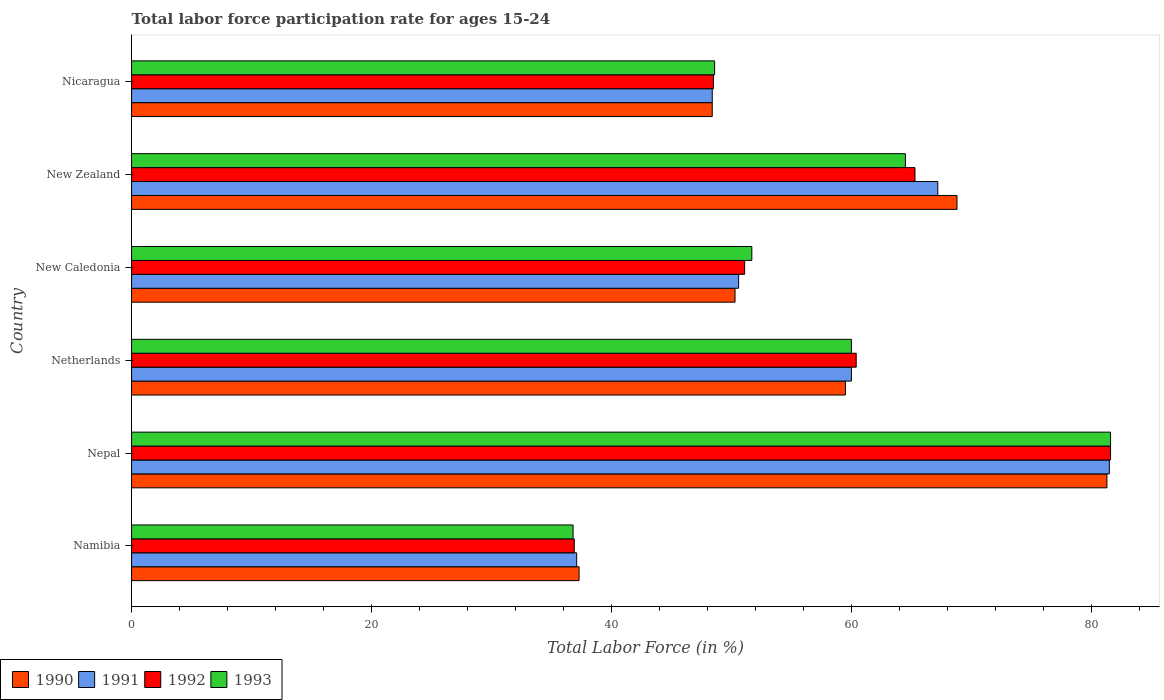How many different coloured bars are there?
Provide a short and direct response. 4. Are the number of bars on each tick of the Y-axis equal?
Ensure brevity in your answer.  Yes. How many bars are there on the 5th tick from the top?
Give a very brief answer. 4. What is the label of the 2nd group of bars from the top?
Make the answer very short. New Zealand. What is the labor force participation rate in 1992 in Namibia?
Keep it short and to the point. 36.9. Across all countries, what is the maximum labor force participation rate in 1993?
Your answer should be very brief. 81.6. Across all countries, what is the minimum labor force participation rate in 1993?
Your answer should be compact. 36.8. In which country was the labor force participation rate in 1990 maximum?
Provide a succinct answer. Nepal. In which country was the labor force participation rate in 1993 minimum?
Your answer should be very brief. Namibia. What is the total labor force participation rate in 1990 in the graph?
Provide a short and direct response. 345.6. What is the difference between the labor force participation rate in 1993 in Namibia and that in Netherlands?
Provide a short and direct response. -23.2. What is the difference between the labor force participation rate in 1992 in Namibia and the labor force participation rate in 1991 in New Zealand?
Provide a short and direct response. -30.3. What is the average labor force participation rate in 1993 per country?
Your answer should be very brief. 57.2. What is the difference between the labor force participation rate in 1990 and labor force participation rate in 1993 in Nicaragua?
Make the answer very short. -0.2. What is the ratio of the labor force participation rate in 1991 in Nepal to that in New Caledonia?
Your response must be concise. 1.61. Is the labor force participation rate in 1990 in Namibia less than that in Nepal?
Make the answer very short. Yes. Is the difference between the labor force participation rate in 1990 in New Caledonia and Nicaragua greater than the difference between the labor force participation rate in 1993 in New Caledonia and Nicaragua?
Ensure brevity in your answer.  No. What is the difference between the highest and the second highest labor force participation rate in 1991?
Your answer should be very brief. 14.3. What is the difference between the highest and the lowest labor force participation rate in 1992?
Your answer should be very brief. 44.7. In how many countries, is the labor force participation rate in 1992 greater than the average labor force participation rate in 1992 taken over all countries?
Offer a terse response. 3. Is the sum of the labor force participation rate in 1993 in Nepal and Netherlands greater than the maximum labor force participation rate in 1992 across all countries?
Give a very brief answer. Yes. Is it the case that in every country, the sum of the labor force participation rate in 1991 and labor force participation rate in 1992 is greater than the sum of labor force participation rate in 1990 and labor force participation rate in 1993?
Provide a short and direct response. No. What does the 1st bar from the top in Namibia represents?
Offer a terse response. 1993. What does the 1st bar from the bottom in Nepal represents?
Provide a short and direct response. 1990. Is it the case that in every country, the sum of the labor force participation rate in 1992 and labor force participation rate in 1991 is greater than the labor force participation rate in 1990?
Ensure brevity in your answer.  Yes. Are all the bars in the graph horizontal?
Your answer should be compact. Yes. Are the values on the major ticks of X-axis written in scientific E-notation?
Keep it short and to the point. No. Where does the legend appear in the graph?
Provide a short and direct response. Bottom left. What is the title of the graph?
Your answer should be very brief. Total labor force participation rate for ages 15-24. What is the Total Labor Force (in %) of 1990 in Namibia?
Provide a succinct answer. 37.3. What is the Total Labor Force (in %) in 1991 in Namibia?
Provide a short and direct response. 37.1. What is the Total Labor Force (in %) of 1992 in Namibia?
Your response must be concise. 36.9. What is the Total Labor Force (in %) of 1993 in Namibia?
Provide a succinct answer. 36.8. What is the Total Labor Force (in %) in 1990 in Nepal?
Your response must be concise. 81.3. What is the Total Labor Force (in %) of 1991 in Nepal?
Make the answer very short. 81.5. What is the Total Labor Force (in %) of 1992 in Nepal?
Provide a short and direct response. 81.6. What is the Total Labor Force (in %) of 1993 in Nepal?
Keep it short and to the point. 81.6. What is the Total Labor Force (in %) of 1990 in Netherlands?
Your answer should be compact. 59.5. What is the Total Labor Force (in %) of 1992 in Netherlands?
Give a very brief answer. 60.4. What is the Total Labor Force (in %) of 1990 in New Caledonia?
Your answer should be very brief. 50.3. What is the Total Labor Force (in %) in 1991 in New Caledonia?
Offer a terse response. 50.6. What is the Total Labor Force (in %) in 1992 in New Caledonia?
Give a very brief answer. 51.1. What is the Total Labor Force (in %) of 1993 in New Caledonia?
Keep it short and to the point. 51.7. What is the Total Labor Force (in %) in 1990 in New Zealand?
Give a very brief answer. 68.8. What is the Total Labor Force (in %) in 1991 in New Zealand?
Offer a terse response. 67.2. What is the Total Labor Force (in %) in 1992 in New Zealand?
Make the answer very short. 65.3. What is the Total Labor Force (in %) in 1993 in New Zealand?
Keep it short and to the point. 64.5. What is the Total Labor Force (in %) in 1990 in Nicaragua?
Your response must be concise. 48.4. What is the Total Labor Force (in %) of 1991 in Nicaragua?
Provide a short and direct response. 48.4. What is the Total Labor Force (in %) of 1992 in Nicaragua?
Give a very brief answer. 48.5. What is the Total Labor Force (in %) of 1993 in Nicaragua?
Give a very brief answer. 48.6. Across all countries, what is the maximum Total Labor Force (in %) in 1990?
Your answer should be very brief. 81.3. Across all countries, what is the maximum Total Labor Force (in %) of 1991?
Ensure brevity in your answer.  81.5. Across all countries, what is the maximum Total Labor Force (in %) of 1992?
Your response must be concise. 81.6. Across all countries, what is the maximum Total Labor Force (in %) of 1993?
Make the answer very short. 81.6. Across all countries, what is the minimum Total Labor Force (in %) of 1990?
Give a very brief answer. 37.3. Across all countries, what is the minimum Total Labor Force (in %) of 1991?
Offer a terse response. 37.1. Across all countries, what is the minimum Total Labor Force (in %) in 1992?
Ensure brevity in your answer.  36.9. Across all countries, what is the minimum Total Labor Force (in %) in 1993?
Give a very brief answer. 36.8. What is the total Total Labor Force (in %) of 1990 in the graph?
Keep it short and to the point. 345.6. What is the total Total Labor Force (in %) of 1991 in the graph?
Your response must be concise. 344.8. What is the total Total Labor Force (in %) in 1992 in the graph?
Provide a succinct answer. 343.8. What is the total Total Labor Force (in %) in 1993 in the graph?
Keep it short and to the point. 343.2. What is the difference between the Total Labor Force (in %) in 1990 in Namibia and that in Nepal?
Your answer should be compact. -44. What is the difference between the Total Labor Force (in %) of 1991 in Namibia and that in Nepal?
Your answer should be compact. -44.4. What is the difference between the Total Labor Force (in %) in 1992 in Namibia and that in Nepal?
Provide a succinct answer. -44.7. What is the difference between the Total Labor Force (in %) of 1993 in Namibia and that in Nepal?
Your response must be concise. -44.8. What is the difference between the Total Labor Force (in %) of 1990 in Namibia and that in Netherlands?
Make the answer very short. -22.2. What is the difference between the Total Labor Force (in %) of 1991 in Namibia and that in Netherlands?
Your answer should be compact. -22.9. What is the difference between the Total Labor Force (in %) in 1992 in Namibia and that in Netherlands?
Offer a very short reply. -23.5. What is the difference between the Total Labor Force (in %) of 1993 in Namibia and that in Netherlands?
Provide a succinct answer. -23.2. What is the difference between the Total Labor Force (in %) of 1990 in Namibia and that in New Caledonia?
Offer a terse response. -13. What is the difference between the Total Labor Force (in %) of 1991 in Namibia and that in New Caledonia?
Your answer should be very brief. -13.5. What is the difference between the Total Labor Force (in %) in 1992 in Namibia and that in New Caledonia?
Your response must be concise. -14.2. What is the difference between the Total Labor Force (in %) in 1993 in Namibia and that in New Caledonia?
Offer a terse response. -14.9. What is the difference between the Total Labor Force (in %) of 1990 in Namibia and that in New Zealand?
Provide a succinct answer. -31.5. What is the difference between the Total Labor Force (in %) of 1991 in Namibia and that in New Zealand?
Make the answer very short. -30.1. What is the difference between the Total Labor Force (in %) of 1992 in Namibia and that in New Zealand?
Provide a succinct answer. -28.4. What is the difference between the Total Labor Force (in %) in 1993 in Namibia and that in New Zealand?
Your response must be concise. -27.7. What is the difference between the Total Labor Force (in %) in 1990 in Namibia and that in Nicaragua?
Make the answer very short. -11.1. What is the difference between the Total Labor Force (in %) of 1992 in Namibia and that in Nicaragua?
Ensure brevity in your answer.  -11.6. What is the difference between the Total Labor Force (in %) of 1990 in Nepal and that in Netherlands?
Give a very brief answer. 21.8. What is the difference between the Total Labor Force (in %) in 1991 in Nepal and that in Netherlands?
Ensure brevity in your answer.  21.5. What is the difference between the Total Labor Force (in %) in 1992 in Nepal and that in Netherlands?
Offer a terse response. 21.2. What is the difference between the Total Labor Force (in %) of 1993 in Nepal and that in Netherlands?
Ensure brevity in your answer.  21.6. What is the difference between the Total Labor Force (in %) in 1991 in Nepal and that in New Caledonia?
Offer a terse response. 30.9. What is the difference between the Total Labor Force (in %) of 1992 in Nepal and that in New Caledonia?
Make the answer very short. 30.5. What is the difference between the Total Labor Force (in %) of 1993 in Nepal and that in New Caledonia?
Provide a short and direct response. 29.9. What is the difference between the Total Labor Force (in %) in 1992 in Nepal and that in New Zealand?
Offer a terse response. 16.3. What is the difference between the Total Labor Force (in %) in 1990 in Nepal and that in Nicaragua?
Keep it short and to the point. 32.9. What is the difference between the Total Labor Force (in %) of 1991 in Nepal and that in Nicaragua?
Ensure brevity in your answer.  33.1. What is the difference between the Total Labor Force (in %) of 1992 in Nepal and that in Nicaragua?
Your response must be concise. 33.1. What is the difference between the Total Labor Force (in %) of 1993 in Nepal and that in Nicaragua?
Keep it short and to the point. 33. What is the difference between the Total Labor Force (in %) in 1991 in Netherlands and that in New Caledonia?
Give a very brief answer. 9.4. What is the difference between the Total Labor Force (in %) in 1993 in Netherlands and that in New Caledonia?
Ensure brevity in your answer.  8.3. What is the difference between the Total Labor Force (in %) in 1991 in Netherlands and that in New Zealand?
Your answer should be very brief. -7.2. What is the difference between the Total Labor Force (in %) of 1993 in Netherlands and that in New Zealand?
Your response must be concise. -4.5. What is the difference between the Total Labor Force (in %) of 1990 in Netherlands and that in Nicaragua?
Your answer should be compact. 11.1. What is the difference between the Total Labor Force (in %) in 1991 in Netherlands and that in Nicaragua?
Your answer should be very brief. 11.6. What is the difference between the Total Labor Force (in %) in 1990 in New Caledonia and that in New Zealand?
Your answer should be compact. -18.5. What is the difference between the Total Labor Force (in %) in 1991 in New Caledonia and that in New Zealand?
Ensure brevity in your answer.  -16.6. What is the difference between the Total Labor Force (in %) in 1992 in New Caledonia and that in Nicaragua?
Your response must be concise. 2.6. What is the difference between the Total Labor Force (in %) of 1990 in New Zealand and that in Nicaragua?
Provide a succinct answer. 20.4. What is the difference between the Total Labor Force (in %) of 1991 in New Zealand and that in Nicaragua?
Ensure brevity in your answer.  18.8. What is the difference between the Total Labor Force (in %) in 1993 in New Zealand and that in Nicaragua?
Your answer should be compact. 15.9. What is the difference between the Total Labor Force (in %) of 1990 in Namibia and the Total Labor Force (in %) of 1991 in Nepal?
Offer a terse response. -44.2. What is the difference between the Total Labor Force (in %) of 1990 in Namibia and the Total Labor Force (in %) of 1992 in Nepal?
Give a very brief answer. -44.3. What is the difference between the Total Labor Force (in %) in 1990 in Namibia and the Total Labor Force (in %) in 1993 in Nepal?
Offer a very short reply. -44.3. What is the difference between the Total Labor Force (in %) in 1991 in Namibia and the Total Labor Force (in %) in 1992 in Nepal?
Your answer should be compact. -44.5. What is the difference between the Total Labor Force (in %) in 1991 in Namibia and the Total Labor Force (in %) in 1993 in Nepal?
Keep it short and to the point. -44.5. What is the difference between the Total Labor Force (in %) of 1992 in Namibia and the Total Labor Force (in %) of 1993 in Nepal?
Your answer should be compact. -44.7. What is the difference between the Total Labor Force (in %) of 1990 in Namibia and the Total Labor Force (in %) of 1991 in Netherlands?
Offer a very short reply. -22.7. What is the difference between the Total Labor Force (in %) of 1990 in Namibia and the Total Labor Force (in %) of 1992 in Netherlands?
Your response must be concise. -23.1. What is the difference between the Total Labor Force (in %) of 1990 in Namibia and the Total Labor Force (in %) of 1993 in Netherlands?
Your answer should be very brief. -22.7. What is the difference between the Total Labor Force (in %) in 1991 in Namibia and the Total Labor Force (in %) in 1992 in Netherlands?
Provide a succinct answer. -23.3. What is the difference between the Total Labor Force (in %) in 1991 in Namibia and the Total Labor Force (in %) in 1993 in Netherlands?
Make the answer very short. -22.9. What is the difference between the Total Labor Force (in %) of 1992 in Namibia and the Total Labor Force (in %) of 1993 in Netherlands?
Make the answer very short. -23.1. What is the difference between the Total Labor Force (in %) of 1990 in Namibia and the Total Labor Force (in %) of 1991 in New Caledonia?
Give a very brief answer. -13.3. What is the difference between the Total Labor Force (in %) of 1990 in Namibia and the Total Labor Force (in %) of 1993 in New Caledonia?
Keep it short and to the point. -14.4. What is the difference between the Total Labor Force (in %) in 1991 in Namibia and the Total Labor Force (in %) in 1992 in New Caledonia?
Ensure brevity in your answer.  -14. What is the difference between the Total Labor Force (in %) in 1991 in Namibia and the Total Labor Force (in %) in 1993 in New Caledonia?
Your response must be concise. -14.6. What is the difference between the Total Labor Force (in %) of 1992 in Namibia and the Total Labor Force (in %) of 1993 in New Caledonia?
Provide a short and direct response. -14.8. What is the difference between the Total Labor Force (in %) in 1990 in Namibia and the Total Labor Force (in %) in 1991 in New Zealand?
Give a very brief answer. -29.9. What is the difference between the Total Labor Force (in %) of 1990 in Namibia and the Total Labor Force (in %) of 1993 in New Zealand?
Ensure brevity in your answer.  -27.2. What is the difference between the Total Labor Force (in %) of 1991 in Namibia and the Total Labor Force (in %) of 1992 in New Zealand?
Provide a short and direct response. -28.2. What is the difference between the Total Labor Force (in %) of 1991 in Namibia and the Total Labor Force (in %) of 1993 in New Zealand?
Offer a very short reply. -27.4. What is the difference between the Total Labor Force (in %) in 1992 in Namibia and the Total Labor Force (in %) in 1993 in New Zealand?
Offer a very short reply. -27.6. What is the difference between the Total Labor Force (in %) of 1990 in Namibia and the Total Labor Force (in %) of 1993 in Nicaragua?
Provide a short and direct response. -11.3. What is the difference between the Total Labor Force (in %) in 1991 in Namibia and the Total Labor Force (in %) in 1992 in Nicaragua?
Offer a very short reply. -11.4. What is the difference between the Total Labor Force (in %) of 1991 in Namibia and the Total Labor Force (in %) of 1993 in Nicaragua?
Give a very brief answer. -11.5. What is the difference between the Total Labor Force (in %) of 1992 in Namibia and the Total Labor Force (in %) of 1993 in Nicaragua?
Provide a short and direct response. -11.7. What is the difference between the Total Labor Force (in %) of 1990 in Nepal and the Total Labor Force (in %) of 1991 in Netherlands?
Your response must be concise. 21.3. What is the difference between the Total Labor Force (in %) of 1990 in Nepal and the Total Labor Force (in %) of 1992 in Netherlands?
Offer a terse response. 20.9. What is the difference between the Total Labor Force (in %) in 1990 in Nepal and the Total Labor Force (in %) in 1993 in Netherlands?
Your response must be concise. 21.3. What is the difference between the Total Labor Force (in %) in 1991 in Nepal and the Total Labor Force (in %) in 1992 in Netherlands?
Provide a succinct answer. 21.1. What is the difference between the Total Labor Force (in %) of 1992 in Nepal and the Total Labor Force (in %) of 1993 in Netherlands?
Your answer should be compact. 21.6. What is the difference between the Total Labor Force (in %) in 1990 in Nepal and the Total Labor Force (in %) in 1991 in New Caledonia?
Keep it short and to the point. 30.7. What is the difference between the Total Labor Force (in %) in 1990 in Nepal and the Total Labor Force (in %) in 1992 in New Caledonia?
Ensure brevity in your answer.  30.2. What is the difference between the Total Labor Force (in %) of 1990 in Nepal and the Total Labor Force (in %) of 1993 in New Caledonia?
Your answer should be compact. 29.6. What is the difference between the Total Labor Force (in %) of 1991 in Nepal and the Total Labor Force (in %) of 1992 in New Caledonia?
Offer a terse response. 30.4. What is the difference between the Total Labor Force (in %) in 1991 in Nepal and the Total Labor Force (in %) in 1993 in New Caledonia?
Provide a succinct answer. 29.8. What is the difference between the Total Labor Force (in %) of 1992 in Nepal and the Total Labor Force (in %) of 1993 in New Caledonia?
Ensure brevity in your answer.  29.9. What is the difference between the Total Labor Force (in %) in 1990 in Nepal and the Total Labor Force (in %) in 1991 in New Zealand?
Ensure brevity in your answer.  14.1. What is the difference between the Total Labor Force (in %) in 1990 in Nepal and the Total Labor Force (in %) in 1992 in New Zealand?
Your answer should be very brief. 16. What is the difference between the Total Labor Force (in %) of 1990 in Nepal and the Total Labor Force (in %) of 1993 in New Zealand?
Keep it short and to the point. 16.8. What is the difference between the Total Labor Force (in %) in 1992 in Nepal and the Total Labor Force (in %) in 1993 in New Zealand?
Keep it short and to the point. 17.1. What is the difference between the Total Labor Force (in %) of 1990 in Nepal and the Total Labor Force (in %) of 1991 in Nicaragua?
Your answer should be very brief. 32.9. What is the difference between the Total Labor Force (in %) in 1990 in Nepal and the Total Labor Force (in %) in 1992 in Nicaragua?
Offer a very short reply. 32.8. What is the difference between the Total Labor Force (in %) in 1990 in Nepal and the Total Labor Force (in %) in 1993 in Nicaragua?
Provide a succinct answer. 32.7. What is the difference between the Total Labor Force (in %) of 1991 in Nepal and the Total Labor Force (in %) of 1993 in Nicaragua?
Your answer should be very brief. 32.9. What is the difference between the Total Labor Force (in %) in 1992 in Nepal and the Total Labor Force (in %) in 1993 in Nicaragua?
Offer a terse response. 33. What is the difference between the Total Labor Force (in %) of 1990 in Netherlands and the Total Labor Force (in %) of 1992 in New Caledonia?
Offer a very short reply. 8.4. What is the difference between the Total Labor Force (in %) of 1992 in Netherlands and the Total Labor Force (in %) of 1993 in New Caledonia?
Give a very brief answer. 8.7. What is the difference between the Total Labor Force (in %) in 1991 in Netherlands and the Total Labor Force (in %) in 1992 in New Zealand?
Give a very brief answer. -5.3. What is the difference between the Total Labor Force (in %) of 1992 in Netherlands and the Total Labor Force (in %) of 1993 in Nicaragua?
Give a very brief answer. 11.8. What is the difference between the Total Labor Force (in %) of 1990 in New Caledonia and the Total Labor Force (in %) of 1991 in New Zealand?
Provide a succinct answer. -16.9. What is the difference between the Total Labor Force (in %) in 1990 in New Caledonia and the Total Labor Force (in %) in 1992 in New Zealand?
Make the answer very short. -15. What is the difference between the Total Labor Force (in %) of 1990 in New Caledonia and the Total Labor Force (in %) of 1993 in New Zealand?
Ensure brevity in your answer.  -14.2. What is the difference between the Total Labor Force (in %) in 1991 in New Caledonia and the Total Labor Force (in %) in 1992 in New Zealand?
Your answer should be compact. -14.7. What is the difference between the Total Labor Force (in %) of 1991 in New Caledonia and the Total Labor Force (in %) of 1993 in New Zealand?
Provide a short and direct response. -13.9. What is the difference between the Total Labor Force (in %) in 1992 in New Caledonia and the Total Labor Force (in %) in 1993 in New Zealand?
Provide a short and direct response. -13.4. What is the difference between the Total Labor Force (in %) in 1990 in New Caledonia and the Total Labor Force (in %) in 1991 in Nicaragua?
Your answer should be compact. 1.9. What is the difference between the Total Labor Force (in %) of 1990 in New Caledonia and the Total Labor Force (in %) of 1992 in Nicaragua?
Your response must be concise. 1.8. What is the difference between the Total Labor Force (in %) in 1991 in New Caledonia and the Total Labor Force (in %) in 1992 in Nicaragua?
Provide a short and direct response. 2.1. What is the difference between the Total Labor Force (in %) of 1991 in New Caledonia and the Total Labor Force (in %) of 1993 in Nicaragua?
Ensure brevity in your answer.  2. What is the difference between the Total Labor Force (in %) in 1992 in New Caledonia and the Total Labor Force (in %) in 1993 in Nicaragua?
Keep it short and to the point. 2.5. What is the difference between the Total Labor Force (in %) in 1990 in New Zealand and the Total Labor Force (in %) in 1991 in Nicaragua?
Make the answer very short. 20.4. What is the difference between the Total Labor Force (in %) of 1990 in New Zealand and the Total Labor Force (in %) of 1992 in Nicaragua?
Ensure brevity in your answer.  20.3. What is the difference between the Total Labor Force (in %) in 1990 in New Zealand and the Total Labor Force (in %) in 1993 in Nicaragua?
Your response must be concise. 20.2. What is the difference between the Total Labor Force (in %) of 1991 in New Zealand and the Total Labor Force (in %) of 1992 in Nicaragua?
Your answer should be very brief. 18.7. What is the difference between the Total Labor Force (in %) of 1992 in New Zealand and the Total Labor Force (in %) of 1993 in Nicaragua?
Your response must be concise. 16.7. What is the average Total Labor Force (in %) in 1990 per country?
Keep it short and to the point. 57.6. What is the average Total Labor Force (in %) in 1991 per country?
Provide a succinct answer. 57.47. What is the average Total Labor Force (in %) of 1992 per country?
Your response must be concise. 57.3. What is the average Total Labor Force (in %) of 1993 per country?
Your answer should be compact. 57.2. What is the difference between the Total Labor Force (in %) of 1990 and Total Labor Force (in %) of 1992 in Namibia?
Keep it short and to the point. 0.4. What is the difference between the Total Labor Force (in %) of 1991 and Total Labor Force (in %) of 1992 in Namibia?
Your answer should be very brief. 0.2. What is the difference between the Total Labor Force (in %) of 1990 and Total Labor Force (in %) of 1992 in Nepal?
Your answer should be compact. -0.3. What is the difference between the Total Labor Force (in %) in 1990 and Total Labor Force (in %) in 1993 in Nepal?
Keep it short and to the point. -0.3. What is the difference between the Total Labor Force (in %) of 1991 and Total Labor Force (in %) of 1992 in Nepal?
Offer a terse response. -0.1. What is the difference between the Total Labor Force (in %) of 1992 and Total Labor Force (in %) of 1993 in Nepal?
Ensure brevity in your answer.  0. What is the difference between the Total Labor Force (in %) of 1990 and Total Labor Force (in %) of 1992 in Netherlands?
Ensure brevity in your answer.  -0.9. What is the difference between the Total Labor Force (in %) of 1991 and Total Labor Force (in %) of 1993 in Netherlands?
Give a very brief answer. 0. What is the difference between the Total Labor Force (in %) of 1992 and Total Labor Force (in %) of 1993 in Netherlands?
Provide a short and direct response. 0.4. What is the difference between the Total Labor Force (in %) in 1990 and Total Labor Force (in %) in 1991 in New Zealand?
Offer a terse response. 1.6. What is the difference between the Total Labor Force (in %) in 1990 and Total Labor Force (in %) in 1993 in New Zealand?
Provide a succinct answer. 4.3. What is the difference between the Total Labor Force (in %) in 1991 and Total Labor Force (in %) in 1992 in New Zealand?
Keep it short and to the point. 1.9. What is the difference between the Total Labor Force (in %) of 1990 and Total Labor Force (in %) of 1991 in Nicaragua?
Your response must be concise. 0. What is the difference between the Total Labor Force (in %) in 1990 and Total Labor Force (in %) in 1992 in Nicaragua?
Your response must be concise. -0.1. What is the difference between the Total Labor Force (in %) of 1990 and Total Labor Force (in %) of 1993 in Nicaragua?
Your answer should be compact. -0.2. What is the ratio of the Total Labor Force (in %) of 1990 in Namibia to that in Nepal?
Give a very brief answer. 0.46. What is the ratio of the Total Labor Force (in %) of 1991 in Namibia to that in Nepal?
Make the answer very short. 0.46. What is the ratio of the Total Labor Force (in %) of 1992 in Namibia to that in Nepal?
Keep it short and to the point. 0.45. What is the ratio of the Total Labor Force (in %) of 1993 in Namibia to that in Nepal?
Offer a very short reply. 0.45. What is the ratio of the Total Labor Force (in %) of 1990 in Namibia to that in Netherlands?
Ensure brevity in your answer.  0.63. What is the ratio of the Total Labor Force (in %) of 1991 in Namibia to that in Netherlands?
Your answer should be compact. 0.62. What is the ratio of the Total Labor Force (in %) in 1992 in Namibia to that in Netherlands?
Provide a short and direct response. 0.61. What is the ratio of the Total Labor Force (in %) of 1993 in Namibia to that in Netherlands?
Keep it short and to the point. 0.61. What is the ratio of the Total Labor Force (in %) of 1990 in Namibia to that in New Caledonia?
Give a very brief answer. 0.74. What is the ratio of the Total Labor Force (in %) of 1991 in Namibia to that in New Caledonia?
Provide a succinct answer. 0.73. What is the ratio of the Total Labor Force (in %) of 1992 in Namibia to that in New Caledonia?
Provide a short and direct response. 0.72. What is the ratio of the Total Labor Force (in %) in 1993 in Namibia to that in New Caledonia?
Offer a terse response. 0.71. What is the ratio of the Total Labor Force (in %) of 1990 in Namibia to that in New Zealand?
Offer a terse response. 0.54. What is the ratio of the Total Labor Force (in %) in 1991 in Namibia to that in New Zealand?
Keep it short and to the point. 0.55. What is the ratio of the Total Labor Force (in %) in 1992 in Namibia to that in New Zealand?
Your answer should be compact. 0.57. What is the ratio of the Total Labor Force (in %) of 1993 in Namibia to that in New Zealand?
Your answer should be compact. 0.57. What is the ratio of the Total Labor Force (in %) in 1990 in Namibia to that in Nicaragua?
Offer a very short reply. 0.77. What is the ratio of the Total Labor Force (in %) in 1991 in Namibia to that in Nicaragua?
Make the answer very short. 0.77. What is the ratio of the Total Labor Force (in %) of 1992 in Namibia to that in Nicaragua?
Offer a very short reply. 0.76. What is the ratio of the Total Labor Force (in %) of 1993 in Namibia to that in Nicaragua?
Offer a terse response. 0.76. What is the ratio of the Total Labor Force (in %) in 1990 in Nepal to that in Netherlands?
Provide a succinct answer. 1.37. What is the ratio of the Total Labor Force (in %) in 1991 in Nepal to that in Netherlands?
Keep it short and to the point. 1.36. What is the ratio of the Total Labor Force (in %) in 1992 in Nepal to that in Netherlands?
Provide a short and direct response. 1.35. What is the ratio of the Total Labor Force (in %) of 1993 in Nepal to that in Netherlands?
Provide a short and direct response. 1.36. What is the ratio of the Total Labor Force (in %) in 1990 in Nepal to that in New Caledonia?
Your answer should be very brief. 1.62. What is the ratio of the Total Labor Force (in %) of 1991 in Nepal to that in New Caledonia?
Make the answer very short. 1.61. What is the ratio of the Total Labor Force (in %) in 1992 in Nepal to that in New Caledonia?
Keep it short and to the point. 1.6. What is the ratio of the Total Labor Force (in %) of 1993 in Nepal to that in New Caledonia?
Make the answer very short. 1.58. What is the ratio of the Total Labor Force (in %) of 1990 in Nepal to that in New Zealand?
Ensure brevity in your answer.  1.18. What is the ratio of the Total Labor Force (in %) in 1991 in Nepal to that in New Zealand?
Make the answer very short. 1.21. What is the ratio of the Total Labor Force (in %) in 1992 in Nepal to that in New Zealand?
Offer a very short reply. 1.25. What is the ratio of the Total Labor Force (in %) in 1993 in Nepal to that in New Zealand?
Make the answer very short. 1.27. What is the ratio of the Total Labor Force (in %) in 1990 in Nepal to that in Nicaragua?
Your answer should be very brief. 1.68. What is the ratio of the Total Labor Force (in %) in 1991 in Nepal to that in Nicaragua?
Provide a short and direct response. 1.68. What is the ratio of the Total Labor Force (in %) in 1992 in Nepal to that in Nicaragua?
Give a very brief answer. 1.68. What is the ratio of the Total Labor Force (in %) in 1993 in Nepal to that in Nicaragua?
Your answer should be compact. 1.68. What is the ratio of the Total Labor Force (in %) of 1990 in Netherlands to that in New Caledonia?
Keep it short and to the point. 1.18. What is the ratio of the Total Labor Force (in %) of 1991 in Netherlands to that in New Caledonia?
Give a very brief answer. 1.19. What is the ratio of the Total Labor Force (in %) in 1992 in Netherlands to that in New Caledonia?
Offer a very short reply. 1.18. What is the ratio of the Total Labor Force (in %) in 1993 in Netherlands to that in New Caledonia?
Your answer should be compact. 1.16. What is the ratio of the Total Labor Force (in %) of 1990 in Netherlands to that in New Zealand?
Make the answer very short. 0.86. What is the ratio of the Total Labor Force (in %) in 1991 in Netherlands to that in New Zealand?
Your answer should be very brief. 0.89. What is the ratio of the Total Labor Force (in %) in 1992 in Netherlands to that in New Zealand?
Your response must be concise. 0.93. What is the ratio of the Total Labor Force (in %) in 1993 in Netherlands to that in New Zealand?
Your response must be concise. 0.93. What is the ratio of the Total Labor Force (in %) of 1990 in Netherlands to that in Nicaragua?
Keep it short and to the point. 1.23. What is the ratio of the Total Labor Force (in %) in 1991 in Netherlands to that in Nicaragua?
Provide a succinct answer. 1.24. What is the ratio of the Total Labor Force (in %) of 1992 in Netherlands to that in Nicaragua?
Keep it short and to the point. 1.25. What is the ratio of the Total Labor Force (in %) of 1993 in Netherlands to that in Nicaragua?
Make the answer very short. 1.23. What is the ratio of the Total Labor Force (in %) in 1990 in New Caledonia to that in New Zealand?
Make the answer very short. 0.73. What is the ratio of the Total Labor Force (in %) in 1991 in New Caledonia to that in New Zealand?
Give a very brief answer. 0.75. What is the ratio of the Total Labor Force (in %) of 1992 in New Caledonia to that in New Zealand?
Keep it short and to the point. 0.78. What is the ratio of the Total Labor Force (in %) of 1993 in New Caledonia to that in New Zealand?
Give a very brief answer. 0.8. What is the ratio of the Total Labor Force (in %) in 1990 in New Caledonia to that in Nicaragua?
Offer a very short reply. 1.04. What is the ratio of the Total Labor Force (in %) of 1991 in New Caledonia to that in Nicaragua?
Offer a very short reply. 1.05. What is the ratio of the Total Labor Force (in %) of 1992 in New Caledonia to that in Nicaragua?
Offer a terse response. 1.05. What is the ratio of the Total Labor Force (in %) of 1993 in New Caledonia to that in Nicaragua?
Provide a succinct answer. 1.06. What is the ratio of the Total Labor Force (in %) in 1990 in New Zealand to that in Nicaragua?
Give a very brief answer. 1.42. What is the ratio of the Total Labor Force (in %) in 1991 in New Zealand to that in Nicaragua?
Give a very brief answer. 1.39. What is the ratio of the Total Labor Force (in %) of 1992 in New Zealand to that in Nicaragua?
Keep it short and to the point. 1.35. What is the ratio of the Total Labor Force (in %) in 1993 in New Zealand to that in Nicaragua?
Your answer should be compact. 1.33. What is the difference between the highest and the second highest Total Labor Force (in %) in 1991?
Keep it short and to the point. 14.3. What is the difference between the highest and the second highest Total Labor Force (in %) in 1992?
Provide a short and direct response. 16.3. What is the difference between the highest and the second highest Total Labor Force (in %) in 1993?
Provide a succinct answer. 17.1. What is the difference between the highest and the lowest Total Labor Force (in %) of 1991?
Make the answer very short. 44.4. What is the difference between the highest and the lowest Total Labor Force (in %) in 1992?
Make the answer very short. 44.7. What is the difference between the highest and the lowest Total Labor Force (in %) in 1993?
Offer a very short reply. 44.8. 